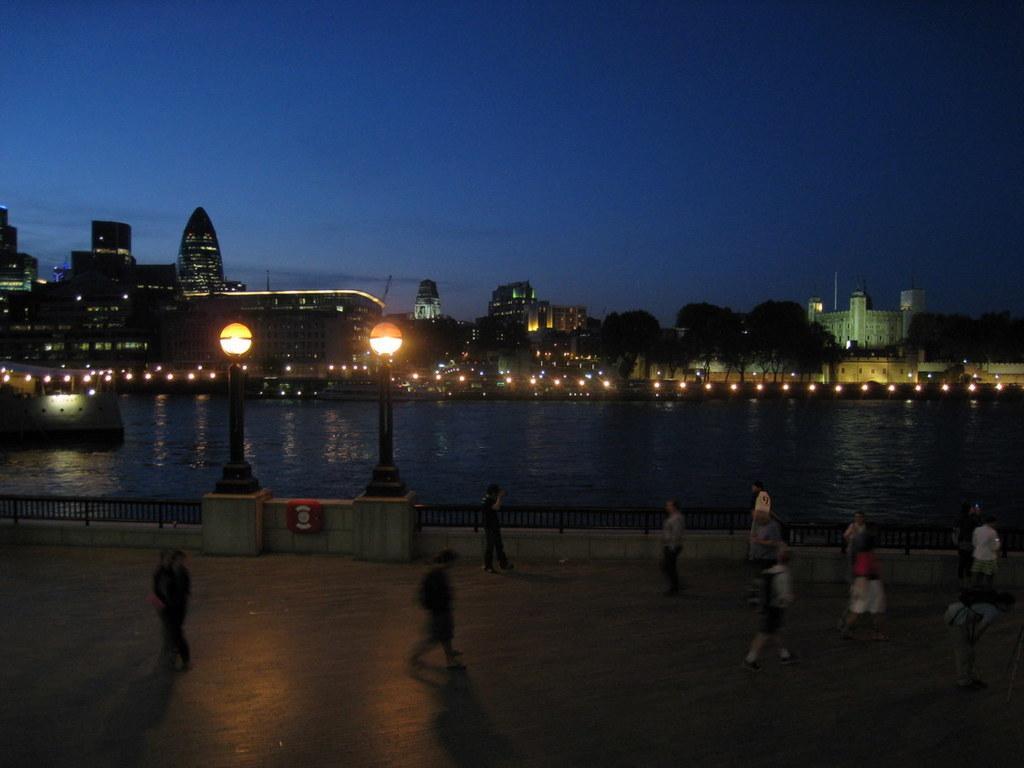Can you describe this image briefly? In this image at the bottom there are group of people walking, and in the center there is a railing, wall, poles, lights and in the background there is a river, buildings, trees and some lights. At the top there is ceiling. 